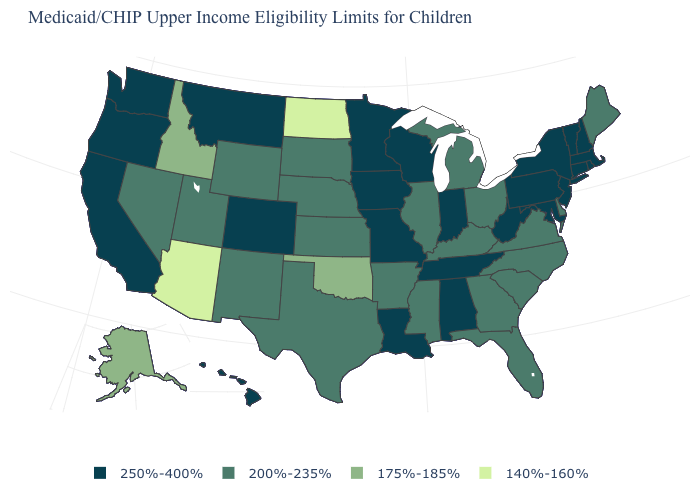Does Louisiana have the highest value in the South?
Concise answer only. Yes. What is the value of Delaware?
Give a very brief answer. 200%-235%. What is the value of Arizona?
Give a very brief answer. 140%-160%. What is the highest value in the USA?
Short answer required. 250%-400%. What is the value of Georgia?
Write a very short answer. 200%-235%. Which states have the lowest value in the Northeast?
Quick response, please. Maine. Name the states that have a value in the range 140%-160%?
Keep it brief. Arizona, North Dakota. Does the map have missing data?
Answer briefly. No. What is the value of Wisconsin?
Short answer required. 250%-400%. What is the value of Kansas?
Quick response, please. 200%-235%. What is the highest value in the MidWest ?
Keep it brief. 250%-400%. How many symbols are there in the legend?
Write a very short answer. 4. Does South Carolina have the same value as Utah?
Write a very short answer. Yes. What is the value of California?
Concise answer only. 250%-400%. What is the highest value in the USA?
Write a very short answer. 250%-400%. 